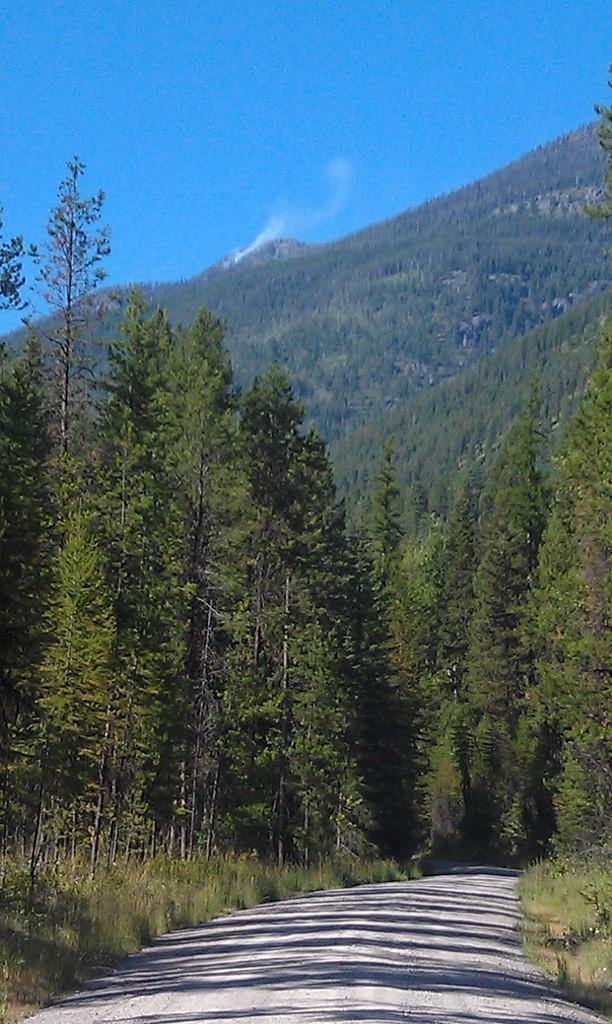What is the main feature of the image? There is a road in the image. What can be seen on both sides of the road? There are trees on both sides of the road. What is the color of the trees? The trees are green in color. What is visible in the background of the image? There is a mountain and the sky in the background of the image. Are there any trees on the mountain? Yes, there are trees on the mountain. What type of poison is being used to treat the trees in the image? There is no indication in the image that any poison is being used to treat the trees. 